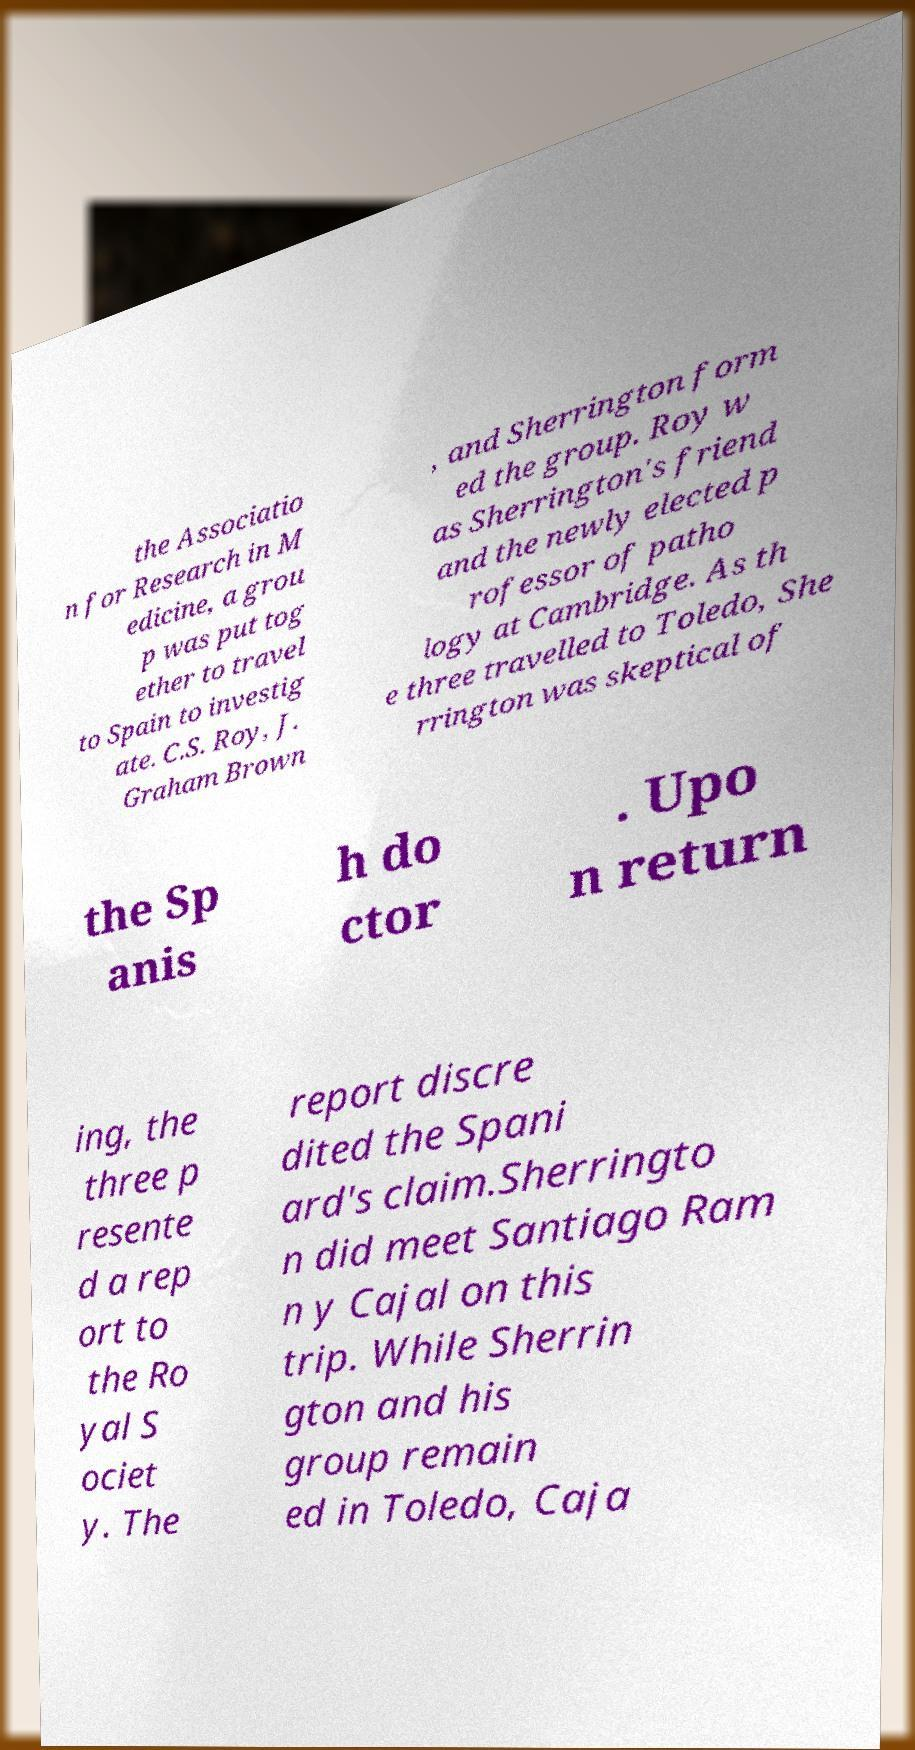Can you read and provide the text displayed in the image?This photo seems to have some interesting text. Can you extract and type it out for me? the Associatio n for Research in M edicine, a grou p was put tog ether to travel to Spain to investig ate. C.S. Roy, J. Graham Brown , and Sherrington form ed the group. Roy w as Sherrington's friend and the newly elected p rofessor of patho logy at Cambridge. As th e three travelled to Toledo, She rrington was skeptical of the Sp anis h do ctor . Upo n return ing, the three p resente d a rep ort to the Ro yal S ociet y. The report discre dited the Spani ard's claim.Sherringto n did meet Santiago Ram n y Cajal on this trip. While Sherrin gton and his group remain ed in Toledo, Caja 